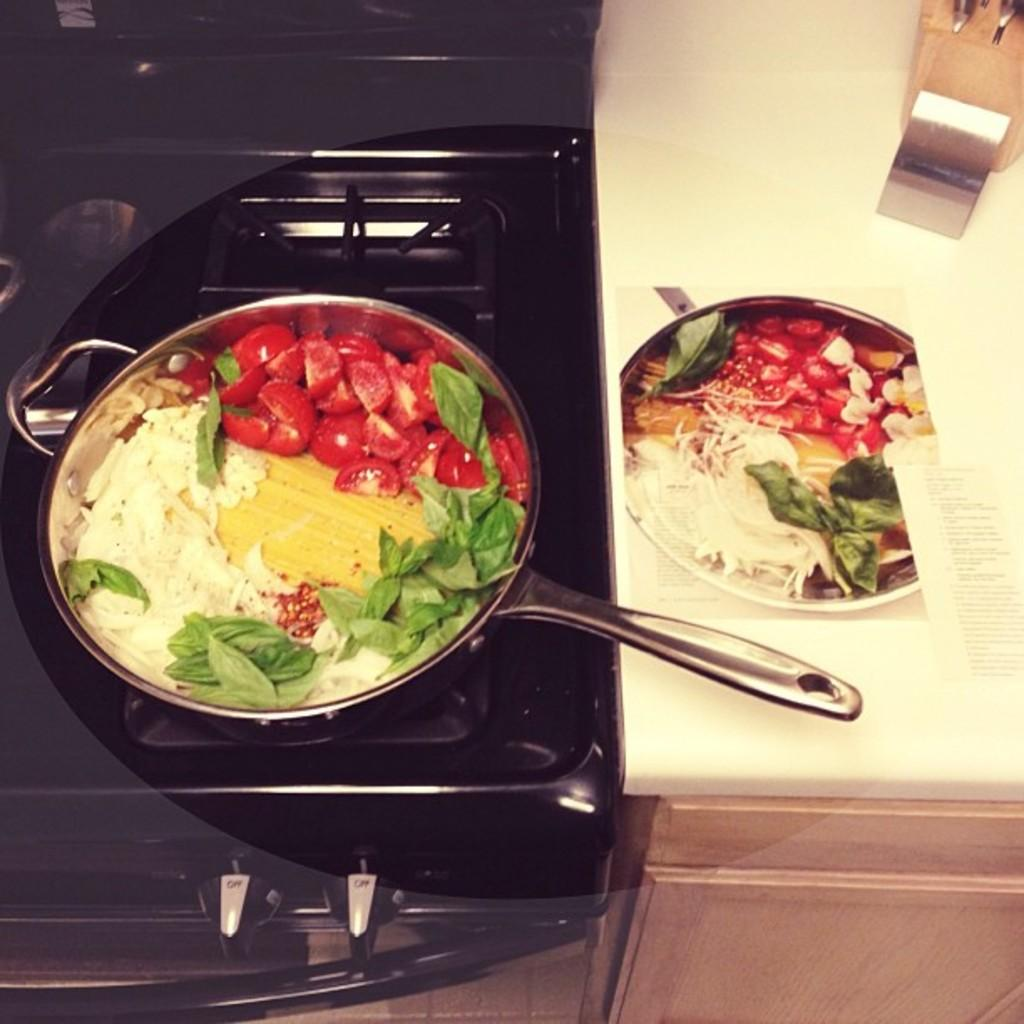What cooking appliance is visible in the image? There is a stove in the image. What is placed on the stove? There is a pan on the stove. What is being cooked in the pan? There is a food item in the pan. What piece of furniture is present in the image? There is a table in the image. What is placed on the table? There is a plate on the table. What food item is on the plate? The plate contains a food item. What type of banana is present in the image? There is no banana present in the image. What is the condition of the low table in the image? There is no mention of a low table in the image, and therefore its condition cannot be determined. 